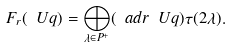<formula> <loc_0><loc_0><loc_500><loc_500>F _ { r } ( \ U q ) = \bigoplus _ { \lambda \in P ^ { + } } ( \ a d r \ U q ) \tau ( 2 \lambda ) .</formula> 